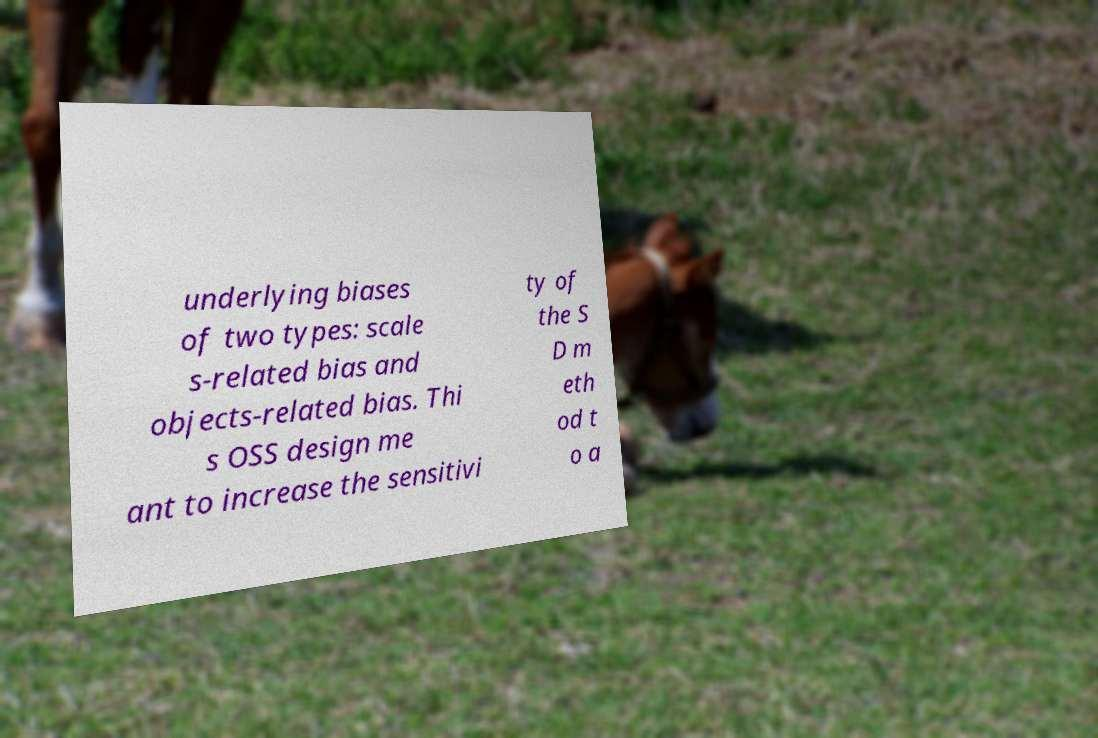What messages or text are displayed in this image? I need them in a readable, typed format. underlying biases of two types: scale s-related bias and objects-related bias. Thi s OSS design me ant to increase the sensitivi ty of the S D m eth od t o a 